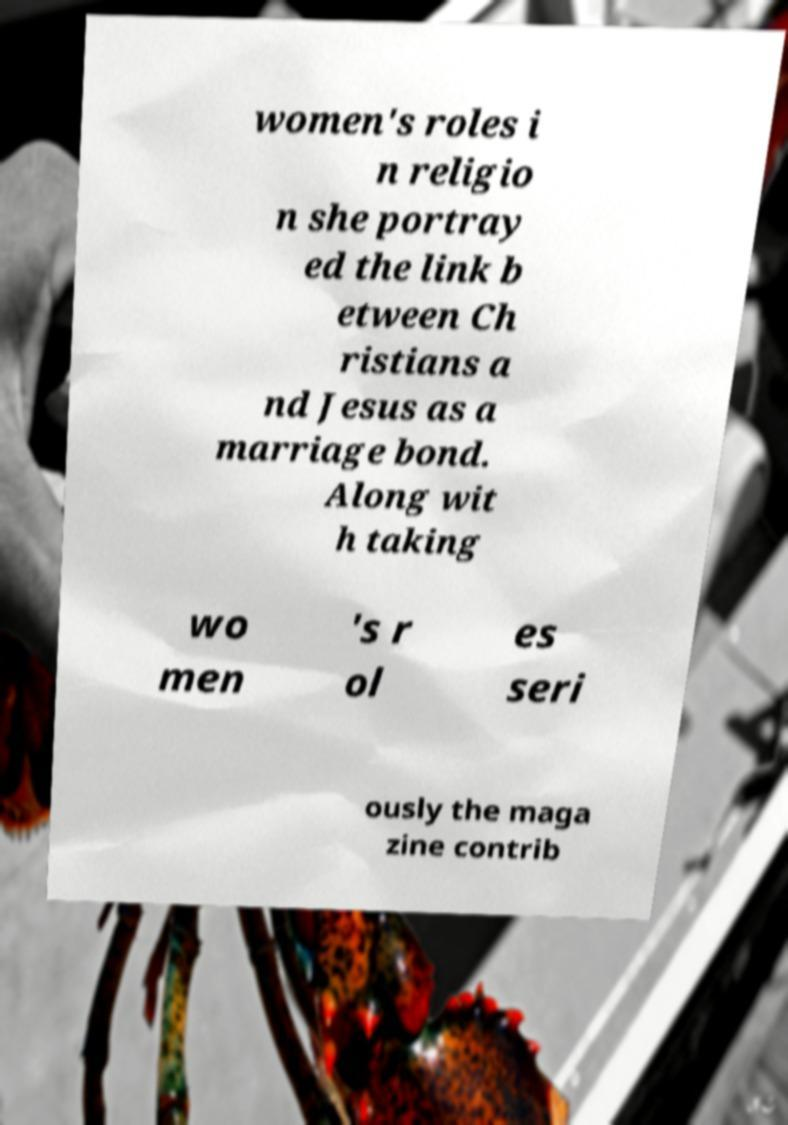Please identify and transcribe the text found in this image. women's roles i n religio n she portray ed the link b etween Ch ristians a nd Jesus as a marriage bond. Along wit h taking wo men 's r ol es seri ously the maga zine contrib 